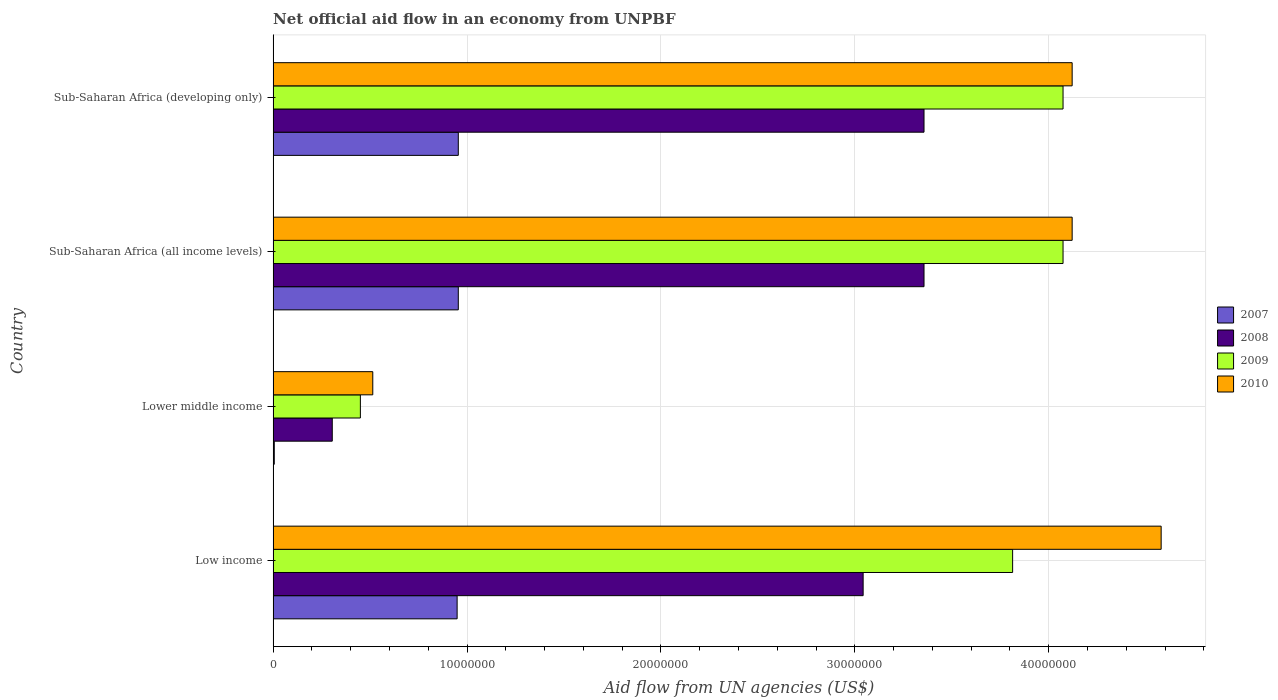How many groups of bars are there?
Your response must be concise. 4. Are the number of bars per tick equal to the number of legend labels?
Ensure brevity in your answer.  Yes. Are the number of bars on each tick of the Y-axis equal?
Your answer should be compact. Yes. How many bars are there on the 1st tick from the bottom?
Your answer should be compact. 4. What is the label of the 1st group of bars from the top?
Keep it short and to the point. Sub-Saharan Africa (developing only). In how many cases, is the number of bars for a given country not equal to the number of legend labels?
Your response must be concise. 0. What is the net official aid flow in 2009 in Sub-Saharan Africa (developing only)?
Ensure brevity in your answer.  4.07e+07. Across all countries, what is the maximum net official aid flow in 2009?
Your response must be concise. 4.07e+07. Across all countries, what is the minimum net official aid flow in 2008?
Provide a succinct answer. 3.05e+06. In which country was the net official aid flow in 2008 maximum?
Give a very brief answer. Sub-Saharan Africa (all income levels). In which country was the net official aid flow in 2010 minimum?
Your answer should be very brief. Lower middle income. What is the total net official aid flow in 2010 in the graph?
Make the answer very short. 1.33e+08. What is the difference between the net official aid flow in 2009 in Low income and that in Sub-Saharan Africa (developing only)?
Give a very brief answer. -2.60e+06. What is the difference between the net official aid flow in 2008 in Sub-Saharan Africa (all income levels) and the net official aid flow in 2010 in Low income?
Offer a very short reply. -1.22e+07. What is the average net official aid flow in 2009 per country?
Make the answer very short. 3.10e+07. What is the difference between the net official aid flow in 2010 and net official aid flow in 2009 in Lower middle income?
Make the answer very short. 6.40e+05. What is the ratio of the net official aid flow in 2007 in Low income to that in Sub-Saharan Africa (developing only)?
Keep it short and to the point. 0.99. Is the difference between the net official aid flow in 2010 in Lower middle income and Sub-Saharan Africa (developing only) greater than the difference between the net official aid flow in 2009 in Lower middle income and Sub-Saharan Africa (developing only)?
Offer a terse response. Yes. What is the difference between the highest and the second highest net official aid flow in 2009?
Give a very brief answer. 0. What is the difference between the highest and the lowest net official aid flow in 2009?
Provide a succinct answer. 3.62e+07. Is it the case that in every country, the sum of the net official aid flow in 2009 and net official aid flow in 2010 is greater than the sum of net official aid flow in 2008 and net official aid flow in 2007?
Offer a very short reply. No. What does the 2nd bar from the bottom in Sub-Saharan Africa (all income levels) represents?
Provide a short and direct response. 2008. Is it the case that in every country, the sum of the net official aid flow in 2010 and net official aid flow in 2007 is greater than the net official aid flow in 2009?
Your response must be concise. Yes. How many bars are there?
Provide a succinct answer. 16. Are all the bars in the graph horizontal?
Provide a succinct answer. Yes. How many countries are there in the graph?
Your answer should be compact. 4. Does the graph contain grids?
Your response must be concise. Yes. Where does the legend appear in the graph?
Provide a short and direct response. Center right. What is the title of the graph?
Your answer should be very brief. Net official aid flow in an economy from UNPBF. What is the label or title of the X-axis?
Offer a very short reply. Aid flow from UN agencies (US$). What is the label or title of the Y-axis?
Offer a very short reply. Country. What is the Aid flow from UN agencies (US$) of 2007 in Low income?
Make the answer very short. 9.49e+06. What is the Aid flow from UN agencies (US$) in 2008 in Low income?
Offer a very short reply. 3.04e+07. What is the Aid flow from UN agencies (US$) in 2009 in Low income?
Keep it short and to the point. 3.81e+07. What is the Aid flow from UN agencies (US$) of 2010 in Low income?
Ensure brevity in your answer.  4.58e+07. What is the Aid flow from UN agencies (US$) in 2008 in Lower middle income?
Ensure brevity in your answer.  3.05e+06. What is the Aid flow from UN agencies (US$) in 2009 in Lower middle income?
Offer a very short reply. 4.50e+06. What is the Aid flow from UN agencies (US$) in 2010 in Lower middle income?
Your answer should be compact. 5.14e+06. What is the Aid flow from UN agencies (US$) in 2007 in Sub-Saharan Africa (all income levels)?
Give a very brief answer. 9.55e+06. What is the Aid flow from UN agencies (US$) in 2008 in Sub-Saharan Africa (all income levels)?
Offer a very short reply. 3.36e+07. What is the Aid flow from UN agencies (US$) in 2009 in Sub-Saharan Africa (all income levels)?
Provide a short and direct response. 4.07e+07. What is the Aid flow from UN agencies (US$) in 2010 in Sub-Saharan Africa (all income levels)?
Provide a short and direct response. 4.12e+07. What is the Aid flow from UN agencies (US$) in 2007 in Sub-Saharan Africa (developing only)?
Provide a short and direct response. 9.55e+06. What is the Aid flow from UN agencies (US$) in 2008 in Sub-Saharan Africa (developing only)?
Offer a very short reply. 3.36e+07. What is the Aid flow from UN agencies (US$) in 2009 in Sub-Saharan Africa (developing only)?
Offer a very short reply. 4.07e+07. What is the Aid flow from UN agencies (US$) in 2010 in Sub-Saharan Africa (developing only)?
Provide a succinct answer. 4.12e+07. Across all countries, what is the maximum Aid flow from UN agencies (US$) in 2007?
Offer a very short reply. 9.55e+06. Across all countries, what is the maximum Aid flow from UN agencies (US$) in 2008?
Provide a succinct answer. 3.36e+07. Across all countries, what is the maximum Aid flow from UN agencies (US$) of 2009?
Give a very brief answer. 4.07e+07. Across all countries, what is the maximum Aid flow from UN agencies (US$) of 2010?
Your answer should be very brief. 4.58e+07. Across all countries, what is the minimum Aid flow from UN agencies (US$) in 2007?
Your response must be concise. 6.00e+04. Across all countries, what is the minimum Aid flow from UN agencies (US$) of 2008?
Offer a terse response. 3.05e+06. Across all countries, what is the minimum Aid flow from UN agencies (US$) of 2009?
Make the answer very short. 4.50e+06. Across all countries, what is the minimum Aid flow from UN agencies (US$) in 2010?
Give a very brief answer. 5.14e+06. What is the total Aid flow from UN agencies (US$) of 2007 in the graph?
Offer a terse response. 2.86e+07. What is the total Aid flow from UN agencies (US$) of 2008 in the graph?
Your answer should be very brief. 1.01e+08. What is the total Aid flow from UN agencies (US$) of 2009 in the graph?
Your response must be concise. 1.24e+08. What is the total Aid flow from UN agencies (US$) in 2010 in the graph?
Your response must be concise. 1.33e+08. What is the difference between the Aid flow from UN agencies (US$) of 2007 in Low income and that in Lower middle income?
Keep it short and to the point. 9.43e+06. What is the difference between the Aid flow from UN agencies (US$) of 2008 in Low income and that in Lower middle income?
Offer a very short reply. 2.74e+07. What is the difference between the Aid flow from UN agencies (US$) of 2009 in Low income and that in Lower middle income?
Make the answer very short. 3.36e+07. What is the difference between the Aid flow from UN agencies (US$) in 2010 in Low income and that in Lower middle income?
Offer a very short reply. 4.07e+07. What is the difference between the Aid flow from UN agencies (US$) in 2008 in Low income and that in Sub-Saharan Africa (all income levels)?
Offer a terse response. -3.14e+06. What is the difference between the Aid flow from UN agencies (US$) in 2009 in Low income and that in Sub-Saharan Africa (all income levels)?
Your answer should be compact. -2.60e+06. What is the difference between the Aid flow from UN agencies (US$) of 2010 in Low income and that in Sub-Saharan Africa (all income levels)?
Your answer should be compact. 4.59e+06. What is the difference between the Aid flow from UN agencies (US$) in 2008 in Low income and that in Sub-Saharan Africa (developing only)?
Provide a short and direct response. -3.14e+06. What is the difference between the Aid flow from UN agencies (US$) of 2009 in Low income and that in Sub-Saharan Africa (developing only)?
Offer a terse response. -2.60e+06. What is the difference between the Aid flow from UN agencies (US$) of 2010 in Low income and that in Sub-Saharan Africa (developing only)?
Provide a short and direct response. 4.59e+06. What is the difference between the Aid flow from UN agencies (US$) of 2007 in Lower middle income and that in Sub-Saharan Africa (all income levels)?
Your answer should be very brief. -9.49e+06. What is the difference between the Aid flow from UN agencies (US$) in 2008 in Lower middle income and that in Sub-Saharan Africa (all income levels)?
Your response must be concise. -3.05e+07. What is the difference between the Aid flow from UN agencies (US$) of 2009 in Lower middle income and that in Sub-Saharan Africa (all income levels)?
Offer a very short reply. -3.62e+07. What is the difference between the Aid flow from UN agencies (US$) in 2010 in Lower middle income and that in Sub-Saharan Africa (all income levels)?
Your answer should be compact. -3.61e+07. What is the difference between the Aid flow from UN agencies (US$) in 2007 in Lower middle income and that in Sub-Saharan Africa (developing only)?
Ensure brevity in your answer.  -9.49e+06. What is the difference between the Aid flow from UN agencies (US$) in 2008 in Lower middle income and that in Sub-Saharan Africa (developing only)?
Offer a very short reply. -3.05e+07. What is the difference between the Aid flow from UN agencies (US$) in 2009 in Lower middle income and that in Sub-Saharan Africa (developing only)?
Your answer should be very brief. -3.62e+07. What is the difference between the Aid flow from UN agencies (US$) of 2010 in Lower middle income and that in Sub-Saharan Africa (developing only)?
Ensure brevity in your answer.  -3.61e+07. What is the difference between the Aid flow from UN agencies (US$) in 2008 in Sub-Saharan Africa (all income levels) and that in Sub-Saharan Africa (developing only)?
Make the answer very short. 0. What is the difference between the Aid flow from UN agencies (US$) of 2009 in Sub-Saharan Africa (all income levels) and that in Sub-Saharan Africa (developing only)?
Provide a succinct answer. 0. What is the difference between the Aid flow from UN agencies (US$) of 2010 in Sub-Saharan Africa (all income levels) and that in Sub-Saharan Africa (developing only)?
Your answer should be compact. 0. What is the difference between the Aid flow from UN agencies (US$) in 2007 in Low income and the Aid flow from UN agencies (US$) in 2008 in Lower middle income?
Provide a short and direct response. 6.44e+06. What is the difference between the Aid flow from UN agencies (US$) of 2007 in Low income and the Aid flow from UN agencies (US$) of 2009 in Lower middle income?
Ensure brevity in your answer.  4.99e+06. What is the difference between the Aid flow from UN agencies (US$) in 2007 in Low income and the Aid flow from UN agencies (US$) in 2010 in Lower middle income?
Ensure brevity in your answer.  4.35e+06. What is the difference between the Aid flow from UN agencies (US$) in 2008 in Low income and the Aid flow from UN agencies (US$) in 2009 in Lower middle income?
Offer a terse response. 2.59e+07. What is the difference between the Aid flow from UN agencies (US$) in 2008 in Low income and the Aid flow from UN agencies (US$) in 2010 in Lower middle income?
Keep it short and to the point. 2.53e+07. What is the difference between the Aid flow from UN agencies (US$) of 2009 in Low income and the Aid flow from UN agencies (US$) of 2010 in Lower middle income?
Your answer should be compact. 3.30e+07. What is the difference between the Aid flow from UN agencies (US$) of 2007 in Low income and the Aid flow from UN agencies (US$) of 2008 in Sub-Saharan Africa (all income levels)?
Give a very brief answer. -2.41e+07. What is the difference between the Aid flow from UN agencies (US$) in 2007 in Low income and the Aid flow from UN agencies (US$) in 2009 in Sub-Saharan Africa (all income levels)?
Keep it short and to the point. -3.12e+07. What is the difference between the Aid flow from UN agencies (US$) of 2007 in Low income and the Aid flow from UN agencies (US$) of 2010 in Sub-Saharan Africa (all income levels)?
Make the answer very short. -3.17e+07. What is the difference between the Aid flow from UN agencies (US$) in 2008 in Low income and the Aid flow from UN agencies (US$) in 2009 in Sub-Saharan Africa (all income levels)?
Your answer should be very brief. -1.03e+07. What is the difference between the Aid flow from UN agencies (US$) of 2008 in Low income and the Aid flow from UN agencies (US$) of 2010 in Sub-Saharan Africa (all income levels)?
Your response must be concise. -1.08e+07. What is the difference between the Aid flow from UN agencies (US$) of 2009 in Low income and the Aid flow from UN agencies (US$) of 2010 in Sub-Saharan Africa (all income levels)?
Ensure brevity in your answer.  -3.07e+06. What is the difference between the Aid flow from UN agencies (US$) in 2007 in Low income and the Aid flow from UN agencies (US$) in 2008 in Sub-Saharan Africa (developing only)?
Ensure brevity in your answer.  -2.41e+07. What is the difference between the Aid flow from UN agencies (US$) of 2007 in Low income and the Aid flow from UN agencies (US$) of 2009 in Sub-Saharan Africa (developing only)?
Your answer should be compact. -3.12e+07. What is the difference between the Aid flow from UN agencies (US$) in 2007 in Low income and the Aid flow from UN agencies (US$) in 2010 in Sub-Saharan Africa (developing only)?
Your answer should be very brief. -3.17e+07. What is the difference between the Aid flow from UN agencies (US$) of 2008 in Low income and the Aid flow from UN agencies (US$) of 2009 in Sub-Saharan Africa (developing only)?
Make the answer very short. -1.03e+07. What is the difference between the Aid flow from UN agencies (US$) of 2008 in Low income and the Aid flow from UN agencies (US$) of 2010 in Sub-Saharan Africa (developing only)?
Your response must be concise. -1.08e+07. What is the difference between the Aid flow from UN agencies (US$) of 2009 in Low income and the Aid flow from UN agencies (US$) of 2010 in Sub-Saharan Africa (developing only)?
Offer a very short reply. -3.07e+06. What is the difference between the Aid flow from UN agencies (US$) in 2007 in Lower middle income and the Aid flow from UN agencies (US$) in 2008 in Sub-Saharan Africa (all income levels)?
Offer a terse response. -3.35e+07. What is the difference between the Aid flow from UN agencies (US$) in 2007 in Lower middle income and the Aid flow from UN agencies (US$) in 2009 in Sub-Saharan Africa (all income levels)?
Offer a very short reply. -4.07e+07. What is the difference between the Aid flow from UN agencies (US$) of 2007 in Lower middle income and the Aid flow from UN agencies (US$) of 2010 in Sub-Saharan Africa (all income levels)?
Offer a terse response. -4.12e+07. What is the difference between the Aid flow from UN agencies (US$) of 2008 in Lower middle income and the Aid flow from UN agencies (US$) of 2009 in Sub-Saharan Africa (all income levels)?
Your response must be concise. -3.77e+07. What is the difference between the Aid flow from UN agencies (US$) of 2008 in Lower middle income and the Aid flow from UN agencies (US$) of 2010 in Sub-Saharan Africa (all income levels)?
Your answer should be very brief. -3.82e+07. What is the difference between the Aid flow from UN agencies (US$) in 2009 in Lower middle income and the Aid flow from UN agencies (US$) in 2010 in Sub-Saharan Africa (all income levels)?
Your answer should be compact. -3.67e+07. What is the difference between the Aid flow from UN agencies (US$) of 2007 in Lower middle income and the Aid flow from UN agencies (US$) of 2008 in Sub-Saharan Africa (developing only)?
Give a very brief answer. -3.35e+07. What is the difference between the Aid flow from UN agencies (US$) of 2007 in Lower middle income and the Aid flow from UN agencies (US$) of 2009 in Sub-Saharan Africa (developing only)?
Your answer should be very brief. -4.07e+07. What is the difference between the Aid flow from UN agencies (US$) in 2007 in Lower middle income and the Aid flow from UN agencies (US$) in 2010 in Sub-Saharan Africa (developing only)?
Make the answer very short. -4.12e+07. What is the difference between the Aid flow from UN agencies (US$) in 2008 in Lower middle income and the Aid flow from UN agencies (US$) in 2009 in Sub-Saharan Africa (developing only)?
Your response must be concise. -3.77e+07. What is the difference between the Aid flow from UN agencies (US$) of 2008 in Lower middle income and the Aid flow from UN agencies (US$) of 2010 in Sub-Saharan Africa (developing only)?
Your answer should be compact. -3.82e+07. What is the difference between the Aid flow from UN agencies (US$) in 2009 in Lower middle income and the Aid flow from UN agencies (US$) in 2010 in Sub-Saharan Africa (developing only)?
Ensure brevity in your answer.  -3.67e+07. What is the difference between the Aid flow from UN agencies (US$) of 2007 in Sub-Saharan Africa (all income levels) and the Aid flow from UN agencies (US$) of 2008 in Sub-Saharan Africa (developing only)?
Ensure brevity in your answer.  -2.40e+07. What is the difference between the Aid flow from UN agencies (US$) of 2007 in Sub-Saharan Africa (all income levels) and the Aid flow from UN agencies (US$) of 2009 in Sub-Saharan Africa (developing only)?
Ensure brevity in your answer.  -3.12e+07. What is the difference between the Aid flow from UN agencies (US$) in 2007 in Sub-Saharan Africa (all income levels) and the Aid flow from UN agencies (US$) in 2010 in Sub-Saharan Africa (developing only)?
Your response must be concise. -3.17e+07. What is the difference between the Aid flow from UN agencies (US$) of 2008 in Sub-Saharan Africa (all income levels) and the Aid flow from UN agencies (US$) of 2009 in Sub-Saharan Africa (developing only)?
Keep it short and to the point. -7.17e+06. What is the difference between the Aid flow from UN agencies (US$) in 2008 in Sub-Saharan Africa (all income levels) and the Aid flow from UN agencies (US$) in 2010 in Sub-Saharan Africa (developing only)?
Give a very brief answer. -7.64e+06. What is the difference between the Aid flow from UN agencies (US$) in 2009 in Sub-Saharan Africa (all income levels) and the Aid flow from UN agencies (US$) in 2010 in Sub-Saharan Africa (developing only)?
Keep it short and to the point. -4.70e+05. What is the average Aid flow from UN agencies (US$) in 2007 per country?
Offer a very short reply. 7.16e+06. What is the average Aid flow from UN agencies (US$) of 2008 per country?
Your answer should be very brief. 2.52e+07. What is the average Aid flow from UN agencies (US$) of 2009 per country?
Provide a short and direct response. 3.10e+07. What is the average Aid flow from UN agencies (US$) in 2010 per country?
Ensure brevity in your answer.  3.33e+07. What is the difference between the Aid flow from UN agencies (US$) of 2007 and Aid flow from UN agencies (US$) of 2008 in Low income?
Provide a short and direct response. -2.09e+07. What is the difference between the Aid flow from UN agencies (US$) in 2007 and Aid flow from UN agencies (US$) in 2009 in Low income?
Keep it short and to the point. -2.86e+07. What is the difference between the Aid flow from UN agencies (US$) in 2007 and Aid flow from UN agencies (US$) in 2010 in Low income?
Your answer should be very brief. -3.63e+07. What is the difference between the Aid flow from UN agencies (US$) of 2008 and Aid flow from UN agencies (US$) of 2009 in Low income?
Provide a short and direct response. -7.71e+06. What is the difference between the Aid flow from UN agencies (US$) in 2008 and Aid flow from UN agencies (US$) in 2010 in Low income?
Make the answer very short. -1.54e+07. What is the difference between the Aid flow from UN agencies (US$) of 2009 and Aid flow from UN agencies (US$) of 2010 in Low income?
Give a very brief answer. -7.66e+06. What is the difference between the Aid flow from UN agencies (US$) of 2007 and Aid flow from UN agencies (US$) of 2008 in Lower middle income?
Your answer should be compact. -2.99e+06. What is the difference between the Aid flow from UN agencies (US$) in 2007 and Aid flow from UN agencies (US$) in 2009 in Lower middle income?
Your answer should be compact. -4.44e+06. What is the difference between the Aid flow from UN agencies (US$) in 2007 and Aid flow from UN agencies (US$) in 2010 in Lower middle income?
Your answer should be compact. -5.08e+06. What is the difference between the Aid flow from UN agencies (US$) of 2008 and Aid flow from UN agencies (US$) of 2009 in Lower middle income?
Offer a terse response. -1.45e+06. What is the difference between the Aid flow from UN agencies (US$) of 2008 and Aid flow from UN agencies (US$) of 2010 in Lower middle income?
Ensure brevity in your answer.  -2.09e+06. What is the difference between the Aid flow from UN agencies (US$) of 2009 and Aid flow from UN agencies (US$) of 2010 in Lower middle income?
Make the answer very short. -6.40e+05. What is the difference between the Aid flow from UN agencies (US$) in 2007 and Aid flow from UN agencies (US$) in 2008 in Sub-Saharan Africa (all income levels)?
Your answer should be very brief. -2.40e+07. What is the difference between the Aid flow from UN agencies (US$) in 2007 and Aid flow from UN agencies (US$) in 2009 in Sub-Saharan Africa (all income levels)?
Keep it short and to the point. -3.12e+07. What is the difference between the Aid flow from UN agencies (US$) of 2007 and Aid flow from UN agencies (US$) of 2010 in Sub-Saharan Africa (all income levels)?
Keep it short and to the point. -3.17e+07. What is the difference between the Aid flow from UN agencies (US$) of 2008 and Aid flow from UN agencies (US$) of 2009 in Sub-Saharan Africa (all income levels)?
Ensure brevity in your answer.  -7.17e+06. What is the difference between the Aid flow from UN agencies (US$) of 2008 and Aid flow from UN agencies (US$) of 2010 in Sub-Saharan Africa (all income levels)?
Your response must be concise. -7.64e+06. What is the difference between the Aid flow from UN agencies (US$) in 2009 and Aid flow from UN agencies (US$) in 2010 in Sub-Saharan Africa (all income levels)?
Give a very brief answer. -4.70e+05. What is the difference between the Aid flow from UN agencies (US$) in 2007 and Aid flow from UN agencies (US$) in 2008 in Sub-Saharan Africa (developing only)?
Provide a short and direct response. -2.40e+07. What is the difference between the Aid flow from UN agencies (US$) in 2007 and Aid flow from UN agencies (US$) in 2009 in Sub-Saharan Africa (developing only)?
Provide a short and direct response. -3.12e+07. What is the difference between the Aid flow from UN agencies (US$) in 2007 and Aid flow from UN agencies (US$) in 2010 in Sub-Saharan Africa (developing only)?
Offer a terse response. -3.17e+07. What is the difference between the Aid flow from UN agencies (US$) in 2008 and Aid flow from UN agencies (US$) in 2009 in Sub-Saharan Africa (developing only)?
Offer a very short reply. -7.17e+06. What is the difference between the Aid flow from UN agencies (US$) of 2008 and Aid flow from UN agencies (US$) of 2010 in Sub-Saharan Africa (developing only)?
Keep it short and to the point. -7.64e+06. What is the difference between the Aid flow from UN agencies (US$) in 2009 and Aid flow from UN agencies (US$) in 2010 in Sub-Saharan Africa (developing only)?
Your answer should be compact. -4.70e+05. What is the ratio of the Aid flow from UN agencies (US$) of 2007 in Low income to that in Lower middle income?
Offer a very short reply. 158.17. What is the ratio of the Aid flow from UN agencies (US$) of 2008 in Low income to that in Lower middle income?
Give a very brief answer. 9.98. What is the ratio of the Aid flow from UN agencies (US$) of 2009 in Low income to that in Lower middle income?
Keep it short and to the point. 8.48. What is the ratio of the Aid flow from UN agencies (US$) in 2010 in Low income to that in Lower middle income?
Your answer should be very brief. 8.91. What is the ratio of the Aid flow from UN agencies (US$) of 2007 in Low income to that in Sub-Saharan Africa (all income levels)?
Keep it short and to the point. 0.99. What is the ratio of the Aid flow from UN agencies (US$) in 2008 in Low income to that in Sub-Saharan Africa (all income levels)?
Keep it short and to the point. 0.91. What is the ratio of the Aid flow from UN agencies (US$) in 2009 in Low income to that in Sub-Saharan Africa (all income levels)?
Provide a short and direct response. 0.94. What is the ratio of the Aid flow from UN agencies (US$) in 2010 in Low income to that in Sub-Saharan Africa (all income levels)?
Make the answer very short. 1.11. What is the ratio of the Aid flow from UN agencies (US$) of 2008 in Low income to that in Sub-Saharan Africa (developing only)?
Provide a short and direct response. 0.91. What is the ratio of the Aid flow from UN agencies (US$) in 2009 in Low income to that in Sub-Saharan Africa (developing only)?
Keep it short and to the point. 0.94. What is the ratio of the Aid flow from UN agencies (US$) in 2010 in Low income to that in Sub-Saharan Africa (developing only)?
Give a very brief answer. 1.11. What is the ratio of the Aid flow from UN agencies (US$) of 2007 in Lower middle income to that in Sub-Saharan Africa (all income levels)?
Your answer should be compact. 0.01. What is the ratio of the Aid flow from UN agencies (US$) of 2008 in Lower middle income to that in Sub-Saharan Africa (all income levels)?
Provide a succinct answer. 0.09. What is the ratio of the Aid flow from UN agencies (US$) of 2009 in Lower middle income to that in Sub-Saharan Africa (all income levels)?
Provide a succinct answer. 0.11. What is the ratio of the Aid flow from UN agencies (US$) in 2010 in Lower middle income to that in Sub-Saharan Africa (all income levels)?
Ensure brevity in your answer.  0.12. What is the ratio of the Aid flow from UN agencies (US$) in 2007 in Lower middle income to that in Sub-Saharan Africa (developing only)?
Your answer should be very brief. 0.01. What is the ratio of the Aid flow from UN agencies (US$) of 2008 in Lower middle income to that in Sub-Saharan Africa (developing only)?
Offer a terse response. 0.09. What is the ratio of the Aid flow from UN agencies (US$) of 2009 in Lower middle income to that in Sub-Saharan Africa (developing only)?
Give a very brief answer. 0.11. What is the ratio of the Aid flow from UN agencies (US$) in 2010 in Lower middle income to that in Sub-Saharan Africa (developing only)?
Ensure brevity in your answer.  0.12. What is the ratio of the Aid flow from UN agencies (US$) in 2009 in Sub-Saharan Africa (all income levels) to that in Sub-Saharan Africa (developing only)?
Your answer should be compact. 1. What is the ratio of the Aid flow from UN agencies (US$) in 2010 in Sub-Saharan Africa (all income levels) to that in Sub-Saharan Africa (developing only)?
Your answer should be very brief. 1. What is the difference between the highest and the second highest Aid flow from UN agencies (US$) in 2007?
Your response must be concise. 0. What is the difference between the highest and the second highest Aid flow from UN agencies (US$) in 2008?
Your answer should be compact. 0. What is the difference between the highest and the second highest Aid flow from UN agencies (US$) of 2010?
Your answer should be compact. 4.59e+06. What is the difference between the highest and the lowest Aid flow from UN agencies (US$) in 2007?
Provide a succinct answer. 9.49e+06. What is the difference between the highest and the lowest Aid flow from UN agencies (US$) in 2008?
Offer a terse response. 3.05e+07. What is the difference between the highest and the lowest Aid flow from UN agencies (US$) of 2009?
Keep it short and to the point. 3.62e+07. What is the difference between the highest and the lowest Aid flow from UN agencies (US$) in 2010?
Make the answer very short. 4.07e+07. 